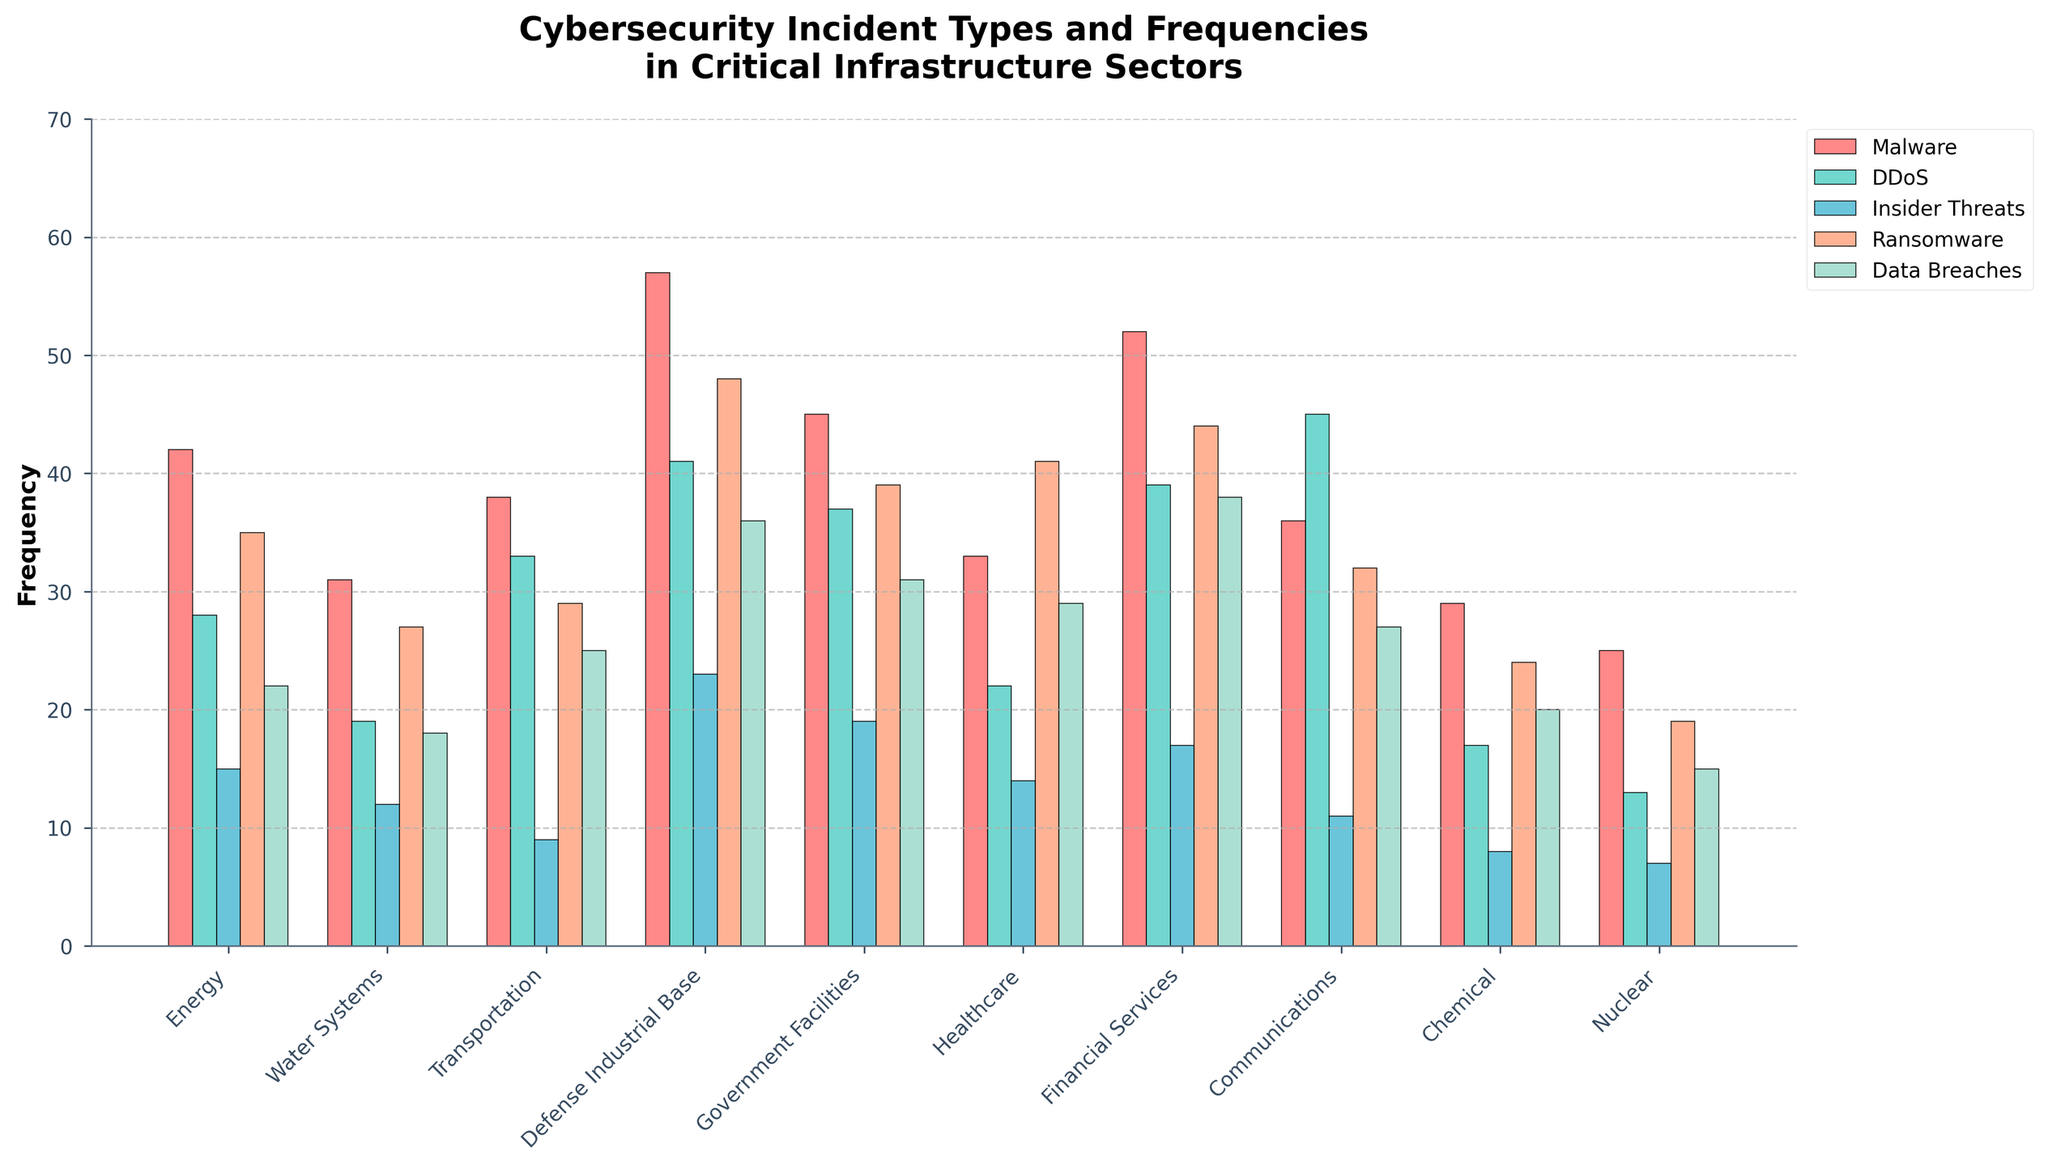Which sector has the highest frequency of Malware incidents? Locate the bar representing Malware incidents for each sector. The Defense Industrial Base has the tallest bar, indicating the highest frequency.
Answer: Defense Industrial Base Which incident type is most frequent in the Financial Services sector? Refer to the bars corresponding to the Financial Services sector and compare their heights. The Data Breaches bar is the highest.
Answer: Data Breaches How many more Data Breaches incidents does Government Facilities have than Nuclear sector? Look at the Data Breaches bar for both sectors and calculate the difference: Government Facilities (31) - Nuclear (15) = 16.
Answer: 16 What is the total frequency of incidents in the Energy sector? Sum the frequencies of all incident types for the Energy sector: 42 (Malware) + 28 (DDoS) + 15 (Insider Threats) + 35 (Ransomware) + 22 (Data Breaches) = 142.
Answer: 142 In which sector is the frequency of DDoS incidents the lowest? Identify the shortest bar for DDoS incidents. The Nuclear sector has the smallest bar, indicating the lowest frequency.
Answer: Nuclear What is the average frequency of Ransomware incidents across all sectors? Sum the Ransomware incidents for all sectors and divide by the number of sectors: (35 + 27 + 29 + 48 + 39 + 41 + 44 + 32 + 24 + 19) / 10 = 33.8.
Answer: 33.8 Compare the frequency of Insider Threats in Healthcare and Chemical sectors. Which one is higher? Compare the height of the Insider Threats bar for both sectors. Healthcare (14) is higher than Chemical (8).
Answer: Healthcare What's the combined total of DDoS incidents in Communications and Transportation sectors? Add the frequencies of DDoS incidents for both sectors: Communications (45) + Transportation (33) = 78.
Answer: 78 Is the frequency of Malware incidents in Communications higher or lower than in Water Systems? Refer to the Malware bar for Communications (36) and Water Systems (31). Communications has a higher value.
Answer: Higher Which sector has the smallest difference between Malware and Ransomware frequencies? Calculate the absolute difference between Malware and Ransomware for each sector, then find the smallest difference: (7 - Nuclear, 2).
Answer: Nuclear 